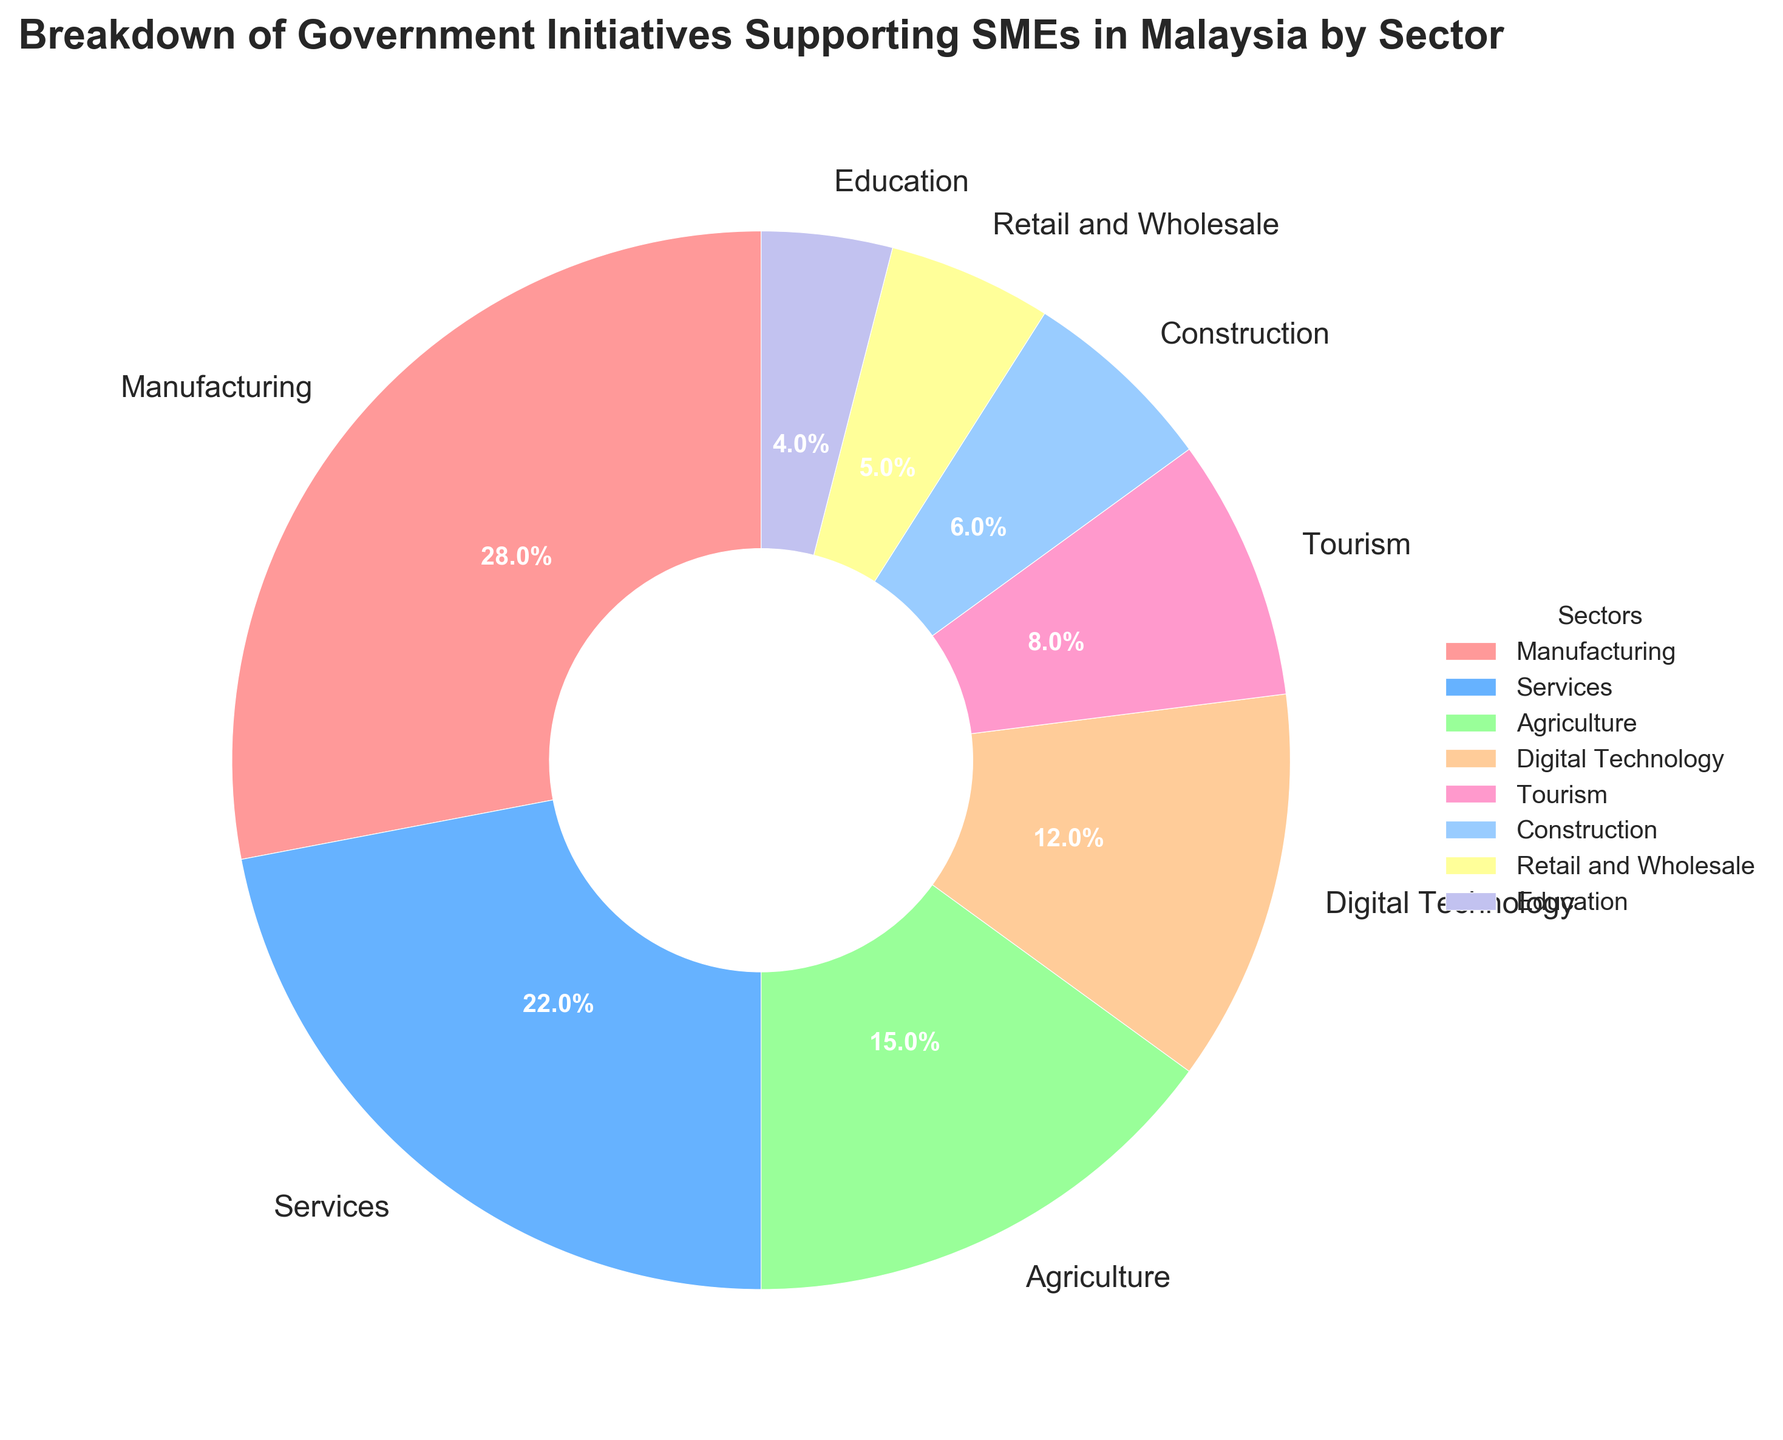What's the largest sector supported by government initiatives for SMEs? The largest sector can be found by looking at the sector with the biggest wedge in the pie chart. The sector with the largest wedge in the chart is Manufacturing at 28%.
Answer: Manufacturing What's the combined percentage of government initiatives supporting the Services and Retail and Wholesale sectors? The Services sector is 22% and the Retail and Wholesale sector is 5%. Adding these percentages together gives 22% + 5% = 27%.
Answer: 27% Which sector receives less support, Construction or Digital Technology, and by how much? Construction receives 6% and Digital Technology receives 12%. Subtracting these percentages gives 12% - 6% = 6%.
Answer: Construction by 6% How much more support does the Manufacturing sector receive compared to the Tourism sector? The Manufacturing sector receives 28% and the Tourism sector receives 8%. Subtracting these percentages gives 28% - 8% = 20%.
Answer: 20% What is the smallest sector in terms of government support for SMEs, and what percentage does it receive? By looking at the pie chart and identifying the smallest wedge, the Education sector is the smallest at 4%.
Answer: Education, 4% What's the total percentage of government initiatives supporting the Agriculture, Tourism, and Construction sectors? Agriculture is 15%, Tourism is 8%, and Construction is 6%. Adding these percentages together gives 15% + 8% + 6% = 29%.
Answer: 29% Does the Services sector receive more combined support than the Agriculture and Retail and Wholesale sectors? The Services sector is 22%, and the combined Agriculture and Retail and Wholesale sectors are 15% + 5% = 20%. Since 22% is greater than 20%, Services receive more combined support.
Answer: Yes Rank the top three sectors that receive the most government support for SMEs. By identifying the three largest wedges, the top three sectors are: 1) Manufacturing (28%), 2) Services (22%), and 3) Agriculture (15%).
Answer: Manufacturing, Services, Agriculture What is the difference in support percentage between the largest and smallest sectors? The largest sector Manufacturing is at 28%, and the smallest sector Education is at 4%. Subtracting these percentages gives 28% - 4% = 24%.
Answer: 24% What is the average support percentage of the top four sectors? The top four sectors by percentage are Manufacturing (28%), Services (22%), Agriculture (15%), and Digital Technology (12%). Adding these percentages and dividing by 4 gives (28% + 22% + 15% + 12%) / 4 = 77 / 4 = 19.25%.
Answer: 19.25% 